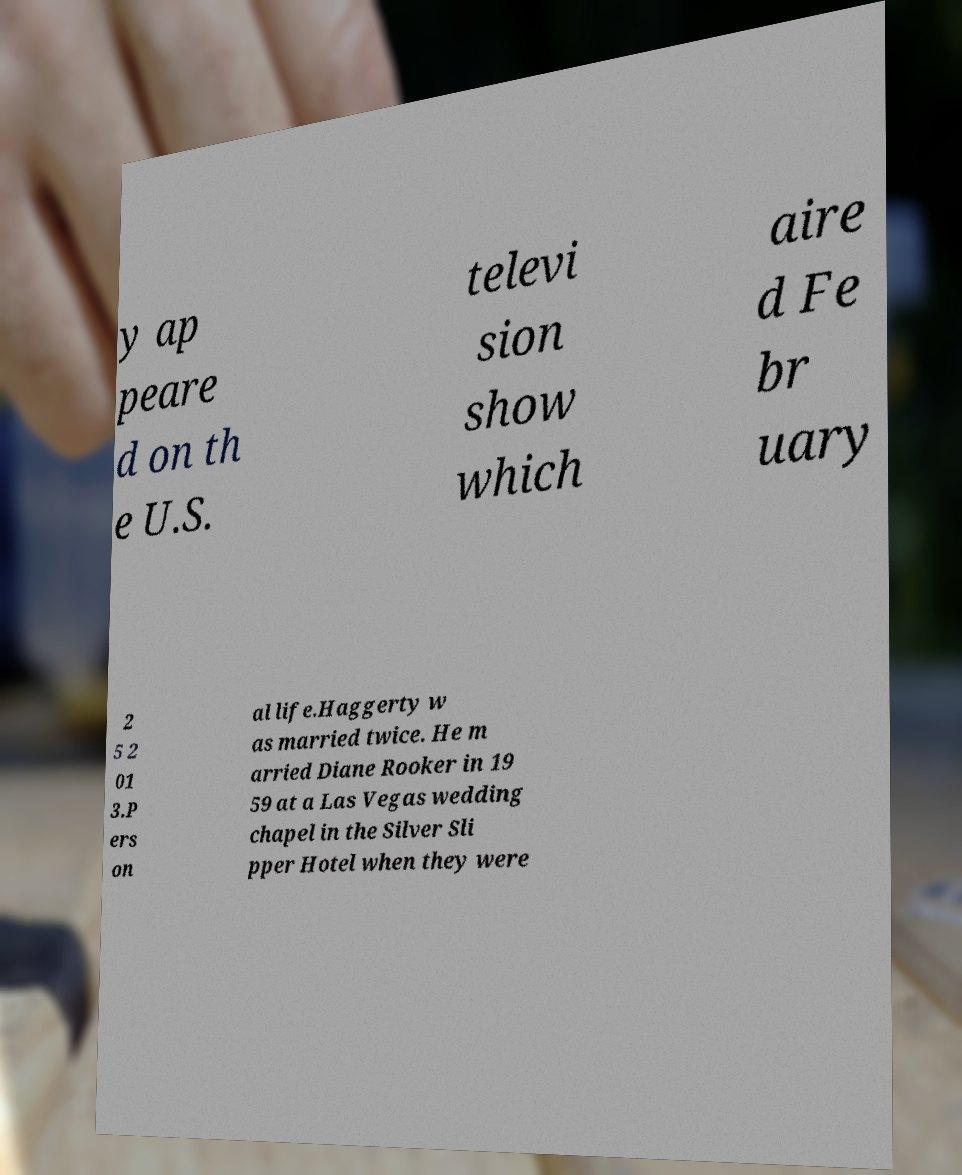Could you extract and type out the text from this image? y ap peare d on th e U.S. televi sion show which aire d Fe br uary 2 5 2 01 3.P ers on al life.Haggerty w as married twice. He m arried Diane Rooker in 19 59 at a Las Vegas wedding chapel in the Silver Sli pper Hotel when they were 